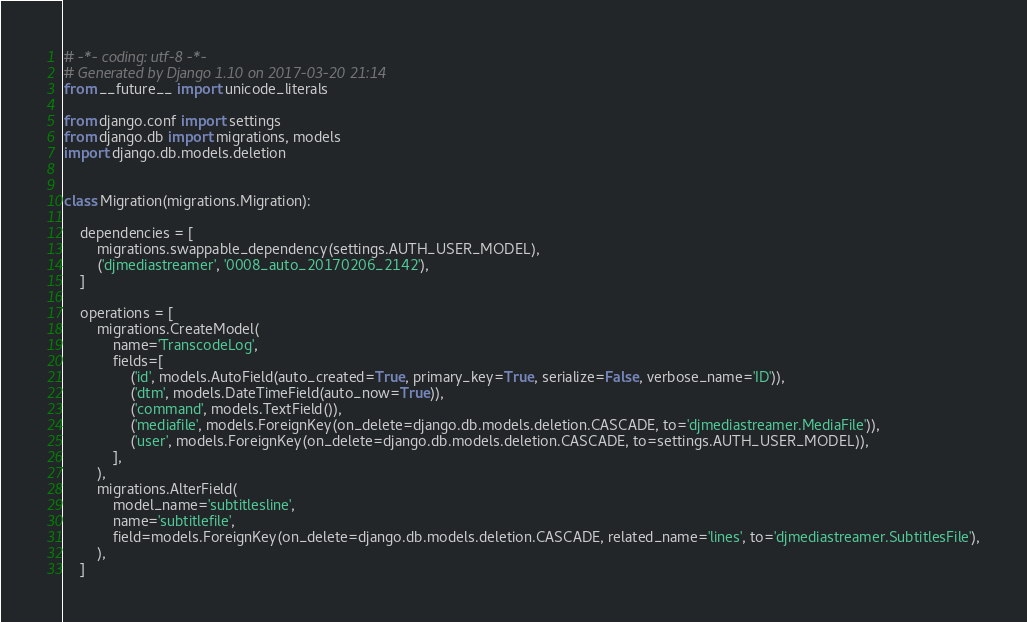<code> <loc_0><loc_0><loc_500><loc_500><_Python_># -*- coding: utf-8 -*-
# Generated by Django 1.10 on 2017-03-20 21:14
from __future__ import unicode_literals

from django.conf import settings
from django.db import migrations, models
import django.db.models.deletion


class Migration(migrations.Migration):

    dependencies = [
        migrations.swappable_dependency(settings.AUTH_USER_MODEL),
        ('djmediastreamer', '0008_auto_20170206_2142'),
    ]

    operations = [
        migrations.CreateModel(
            name='TranscodeLog',
            fields=[
                ('id', models.AutoField(auto_created=True, primary_key=True, serialize=False, verbose_name='ID')),
                ('dtm', models.DateTimeField(auto_now=True)),
                ('command', models.TextField()),
                ('mediafile', models.ForeignKey(on_delete=django.db.models.deletion.CASCADE, to='djmediastreamer.MediaFile')),
                ('user', models.ForeignKey(on_delete=django.db.models.deletion.CASCADE, to=settings.AUTH_USER_MODEL)),
            ],
        ),
        migrations.AlterField(
            model_name='subtitlesline',
            name='subtitlefile',
            field=models.ForeignKey(on_delete=django.db.models.deletion.CASCADE, related_name='lines', to='djmediastreamer.SubtitlesFile'),
        ),
    ]
</code> 